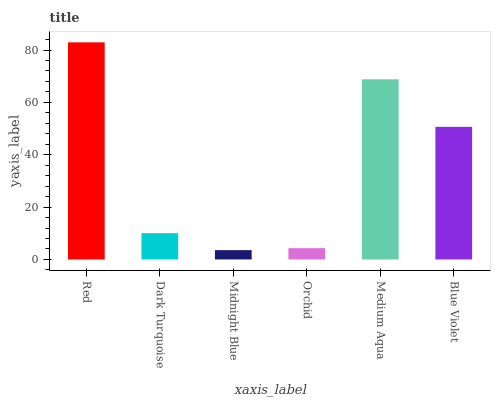Is Midnight Blue the minimum?
Answer yes or no. Yes. Is Red the maximum?
Answer yes or no. Yes. Is Dark Turquoise the minimum?
Answer yes or no. No. Is Dark Turquoise the maximum?
Answer yes or no. No. Is Red greater than Dark Turquoise?
Answer yes or no. Yes. Is Dark Turquoise less than Red?
Answer yes or no. Yes. Is Dark Turquoise greater than Red?
Answer yes or no. No. Is Red less than Dark Turquoise?
Answer yes or no. No. Is Blue Violet the high median?
Answer yes or no. Yes. Is Dark Turquoise the low median?
Answer yes or no. Yes. Is Red the high median?
Answer yes or no. No. Is Red the low median?
Answer yes or no. No. 